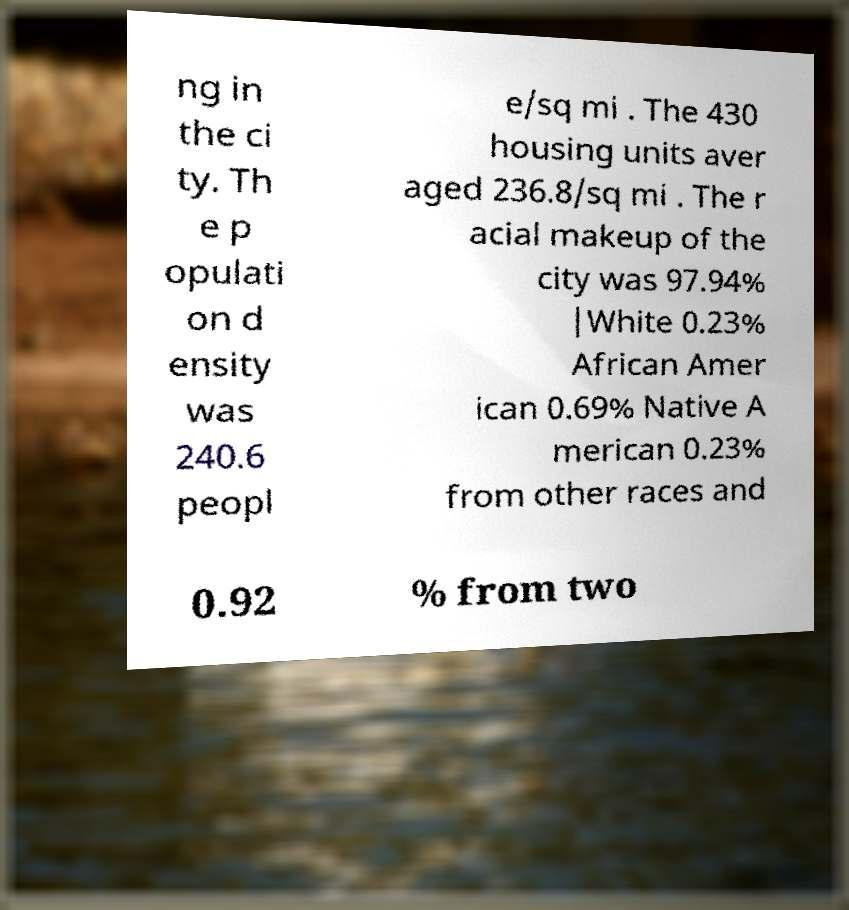Could you assist in decoding the text presented in this image and type it out clearly? ng in the ci ty. Th e p opulati on d ensity was 240.6 peopl e/sq mi . The 430 housing units aver aged 236.8/sq mi . The r acial makeup of the city was 97.94% |White 0.23% African Amer ican 0.69% Native A merican 0.23% from other races and 0.92 % from two 